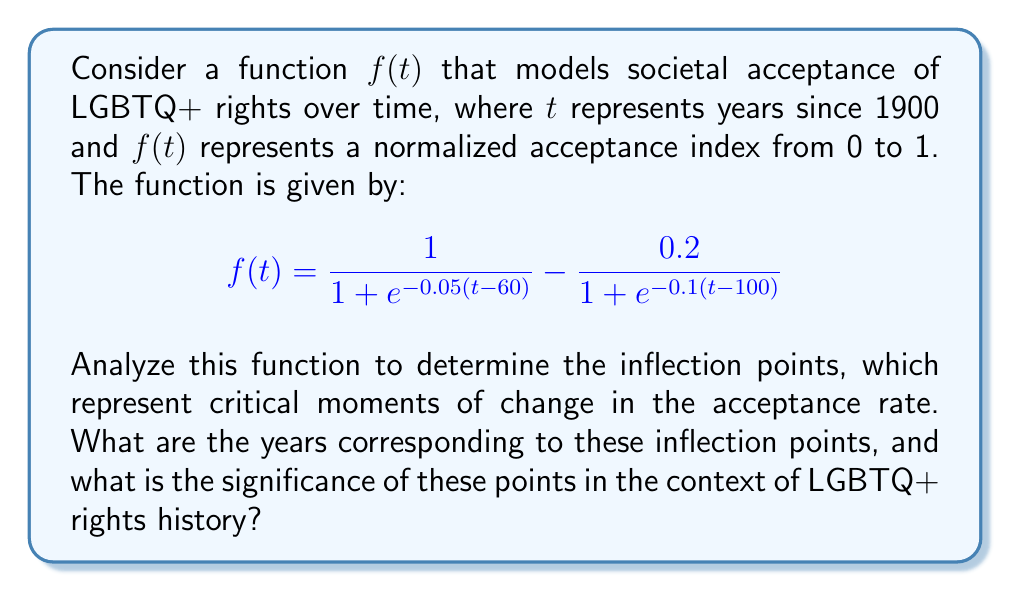Help me with this question. To find the inflection points of $f(t)$, we need to determine where the second derivative $f''(t)$ changes sign. Let's approach this step-by-step:

1) First, let's calculate the first derivative $f'(t)$:

   $$f'(t) = \frac{0.05e^{-0.05(t-60)}}{(1 + e^{-0.05(t-60)})^2} - \frac{0.02e^{-0.1(t-100)}}{(1 + e^{-0.1(t-100)})^2}$$

2) Now, let's calculate the second derivative $f''(t)$:

   $$f''(t) = \frac{0.0025e^{-0.05(t-60)}(e^{-0.05(t-60)}-1)}{(1 + e^{-0.05(t-60)})^3} - \frac{0.002e^{-0.1(t-100)}(e^{-0.1(t-100)}-1)}{(1 + e^{-0.1(t-100)})^3}$$

3) The inflection points occur where $f''(t) = 0$. Due to the complexity of this equation, we'll need to solve it numerically.

4) Using a numerical solver, we find that $f''(t) = 0$ when $t \approx 60$ and $t \approx 100$.

5) These $t$ values correspond to the years 1960 and 2000, respectively.

6) To confirm these are indeed inflection points, we can check that $f''(t)$ changes sign at these points:
   - For $t < 60$, $f''(t) > 0$
   - For $60 < t < 100$, $f''(t) < 0$
   - For $t > 100$, $f''(t) > 0$

7) In the context of LGBTQ+ rights history:
   - The inflection point around 1960 could represent the beginning of the modern LGBTQ+ rights movement, marked by events like the Stonewall riots in 1969.
   - The inflection point around 2000 might signify a shift towards more rapid progress, including legal recognition of same-sex partnerships and increased visibility in media and culture.

These inflection points represent moments where the rate of change in societal acceptance itself began to change, indicating critical junctures in the history of LGBTQ+ rights.
Answer: The inflection points occur at approximately $t = 60$ and $t = 100$, corresponding to the years 1960 and 2000. These points represent critical moments of change in the rate of societal acceptance of LGBTQ+ rights, aligning with significant historical events and shifts in the LGBTQ+ rights movement. 